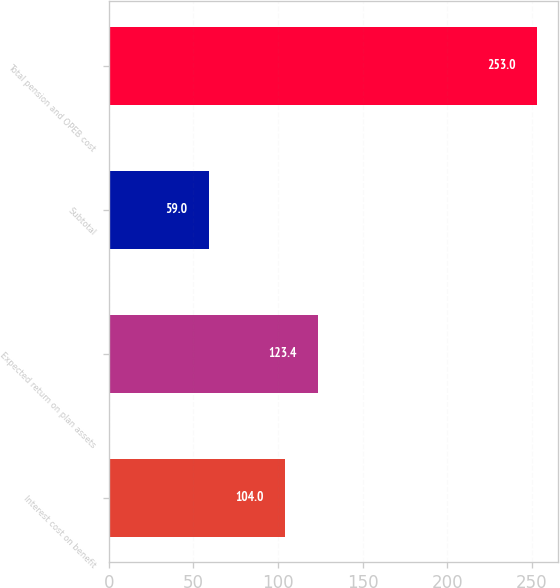<chart> <loc_0><loc_0><loc_500><loc_500><bar_chart><fcel>Interest cost on benefit<fcel>Expected return on plan assets<fcel>Subtotal<fcel>Total pension and OPEB cost<nl><fcel>104<fcel>123.4<fcel>59<fcel>253<nl></chart> 